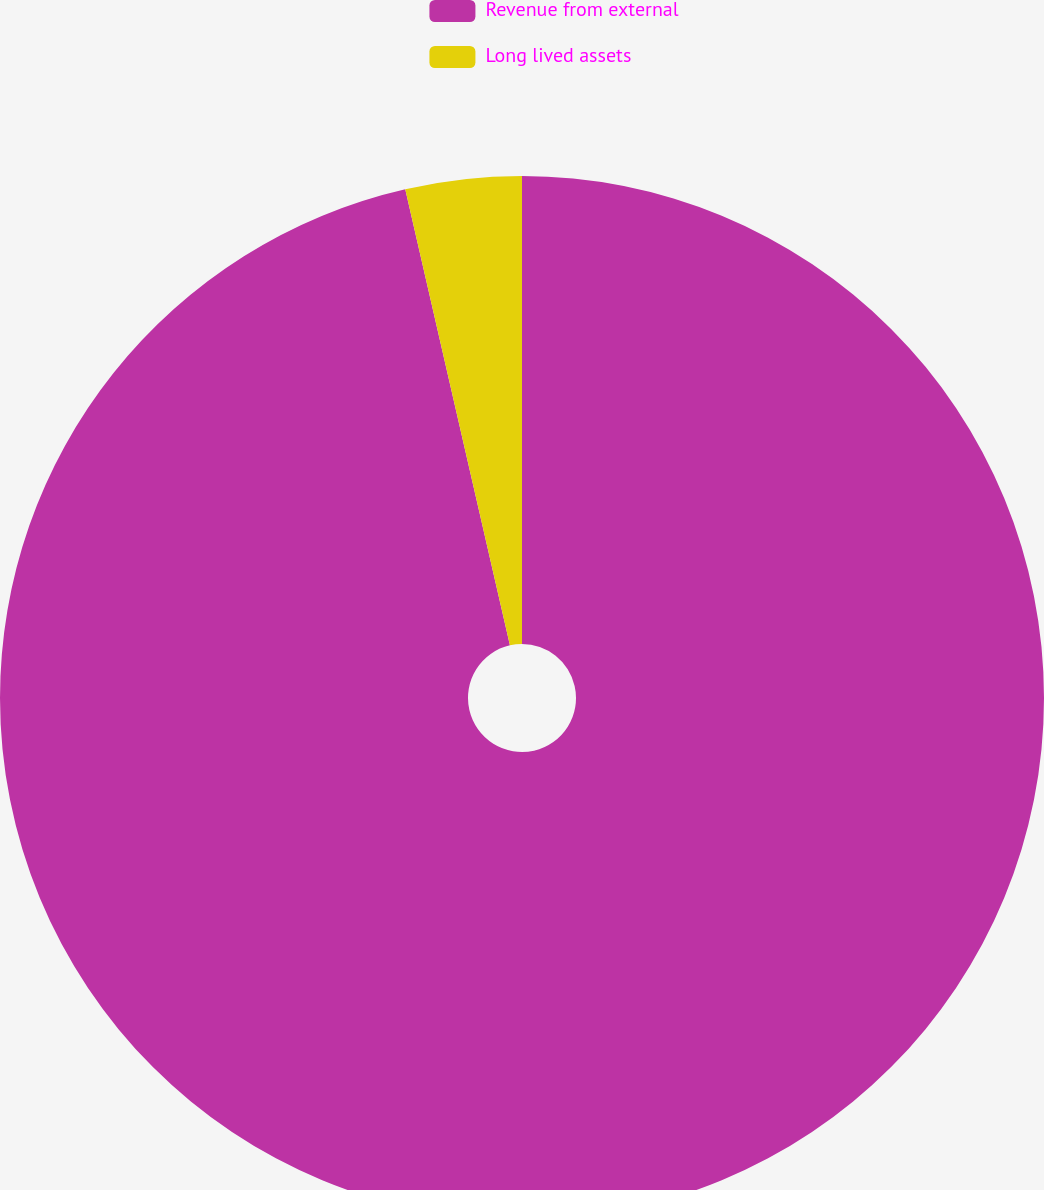Convert chart to OTSL. <chart><loc_0><loc_0><loc_500><loc_500><pie_chart><fcel>Revenue from external<fcel>Long lived assets<nl><fcel>96.41%<fcel>3.59%<nl></chart> 